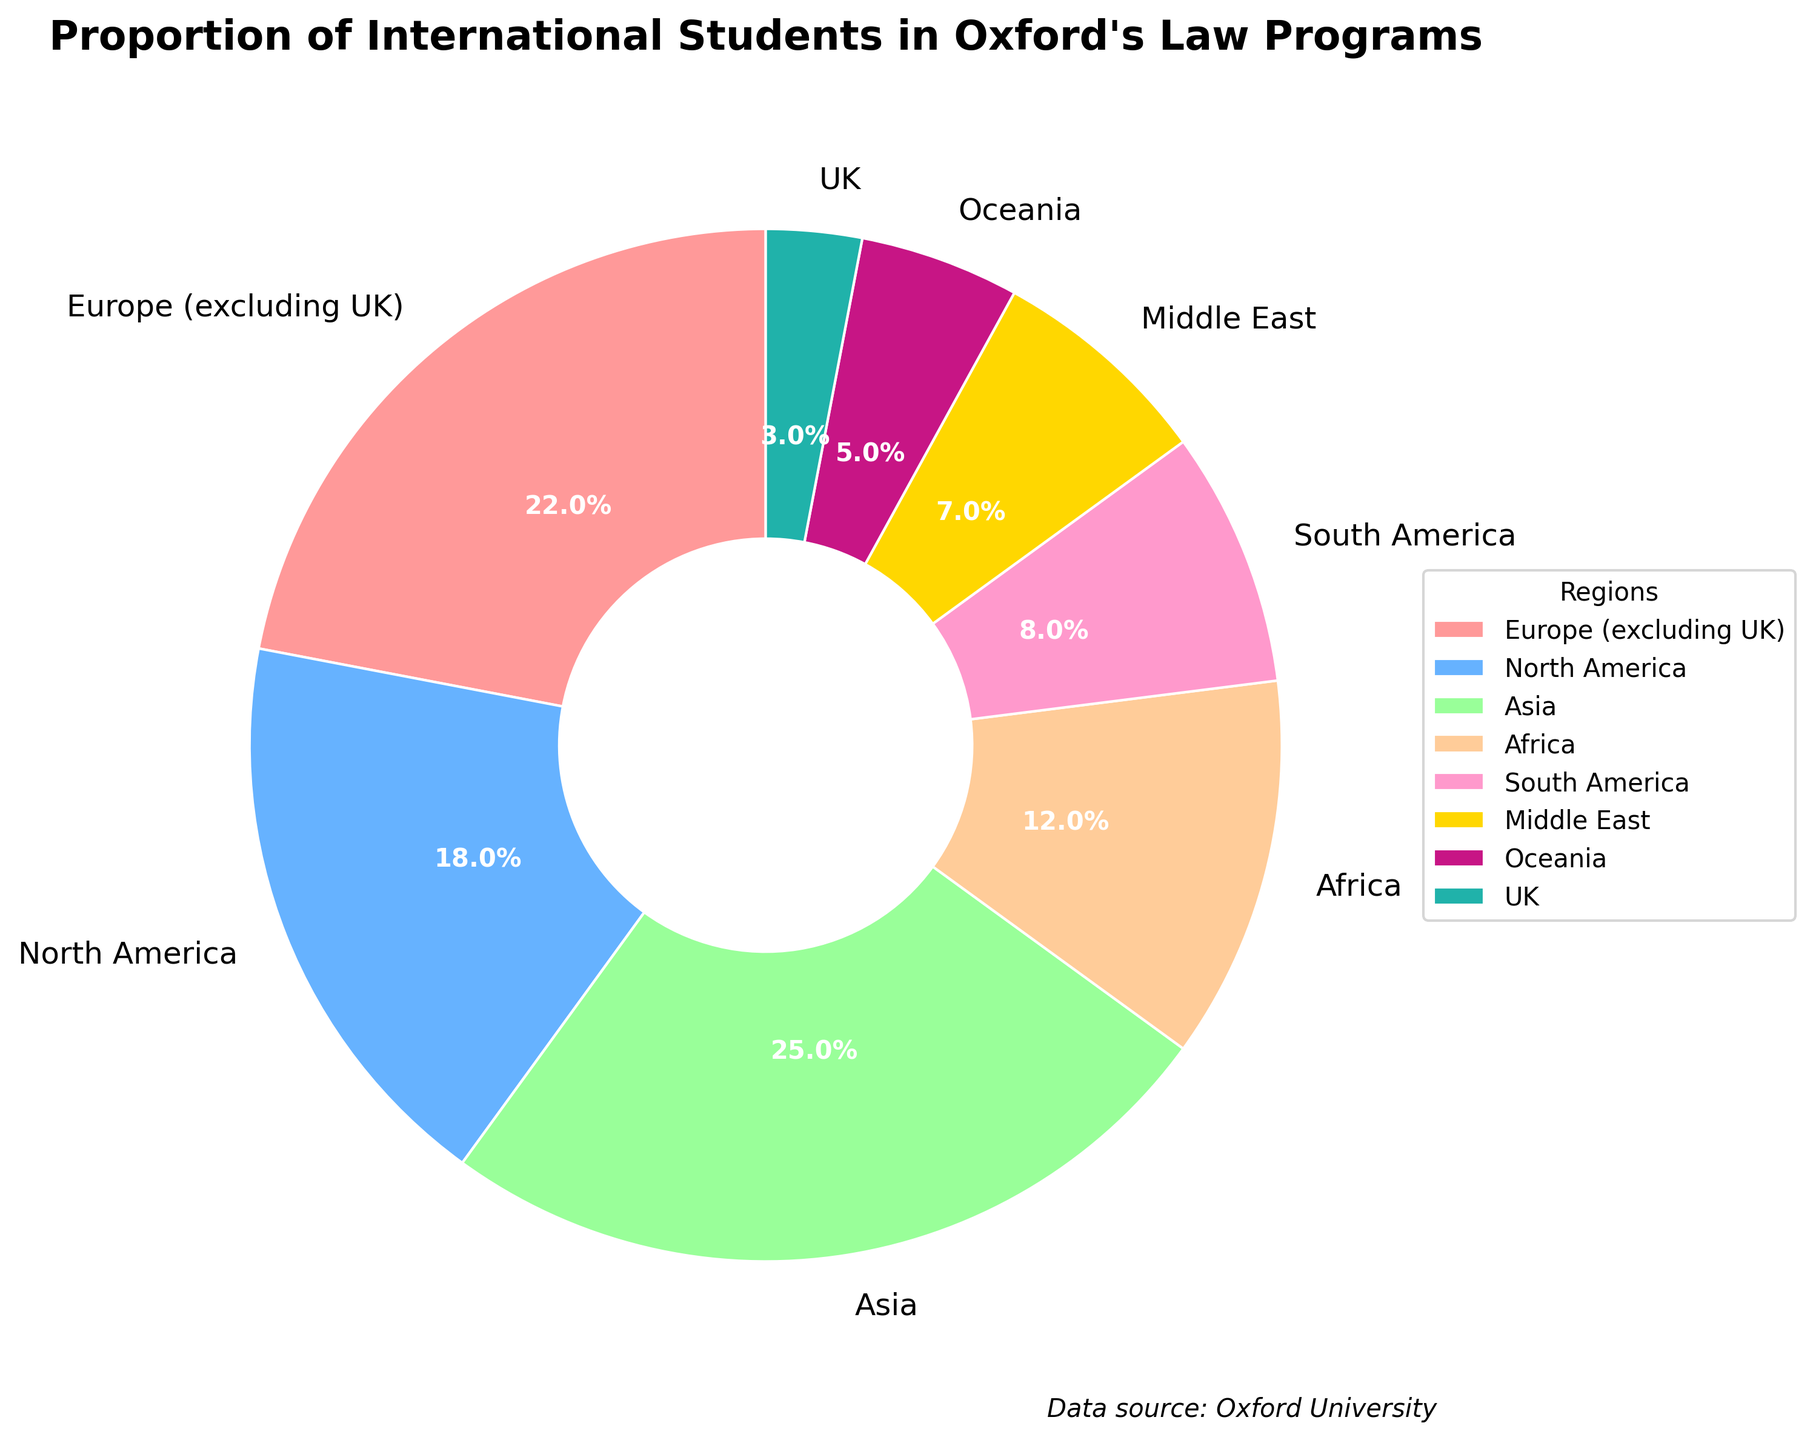Which region has the largest proportion of international students in Oxford's law programs? The largest section of the pie chart is labeled 'Asia', and it takes up the highest percentage of the chart.
Answer: Asia Which two regions combined have a proportion equal to that of Asia? The proportions for North America and Europe (excluding UK) are 18% and 22% respectively. Adding both (18 + 22) equals 40%, which is the same as the proportion of Asia.
Answer: Europe (excluding UK) and North America What is the combined proportion of students from Africa and the Middle East? The proportions for Africa and the Middle East are 12% and 7% respectively. Adding them gives 12 + 7 = 19%.
Answer: 19% Which region has the smallest proportion of international students in Oxford's law programs? The smallest section of the pie chart is labeled 'UK', and it takes up the smallest percentage of the chart at 3%.
Answer: UK What is the difference in percentage between students from South America and Europe (excluding UK)? The proportion for South America is 8% and for Europe (excluding UK) is 22%. The difference is 22 - 8 = 14%.
Answer: 14% How many regions have a proportion greater than 10%? Observing the pie chart, the regions with a proportion greater than 10% are Europe (excluding UK), North America, Asia, and Africa. Counting these regions gives 4.
Answer: 4 Which region has a proportion closest to the average proportion across all regions? The average proportion can be calculated by summing all the percentages and dividing by the number of regions: (22 + 18 + 25 + 12 + 8 + 7 + 5 + 3) / 8 = 100 / 8 = 12.5%. The region with the percentage closest to 12.5% is Africa with 12%.
Answer: Africa What is the visual color for the proportion representing Oceania? In the pie chart, Oceania is represented by the section colored light green.
Answer: light green If the proportions of Europe (excluding UK) and North America were swapped, what percentage would North America then represent? Europe (excluding UK) currently has a proportion of 22%. If the proportions were swapped, North America would represent 22%.
Answer: 22% What is the total percentage of students from regions other than Asia? The proportion for Asia is 25%. The total percentage for other regions is 100 - 25 = 75%.
Answer: 75% 